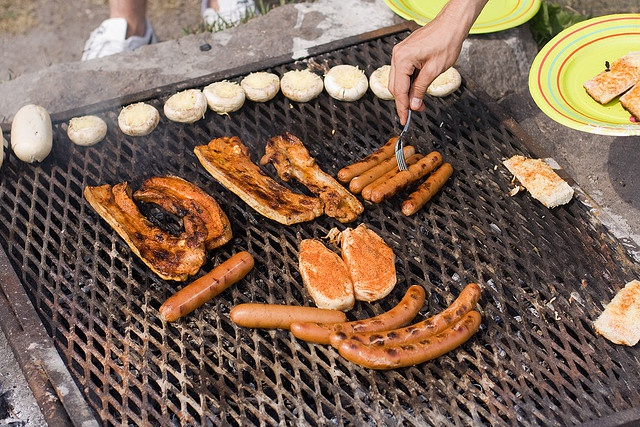Describe the objects in this image and their specific colors. I can see hot dog in gray, brown, salmon, and red tones, people in gray, tan, salmon, and brown tones, people in gray, lightgray, darkgray, and tan tones, hot dog in gray, red, brown, maroon, and salmon tones, and hot dog in gray, brown, salmon, and red tones in this image. 